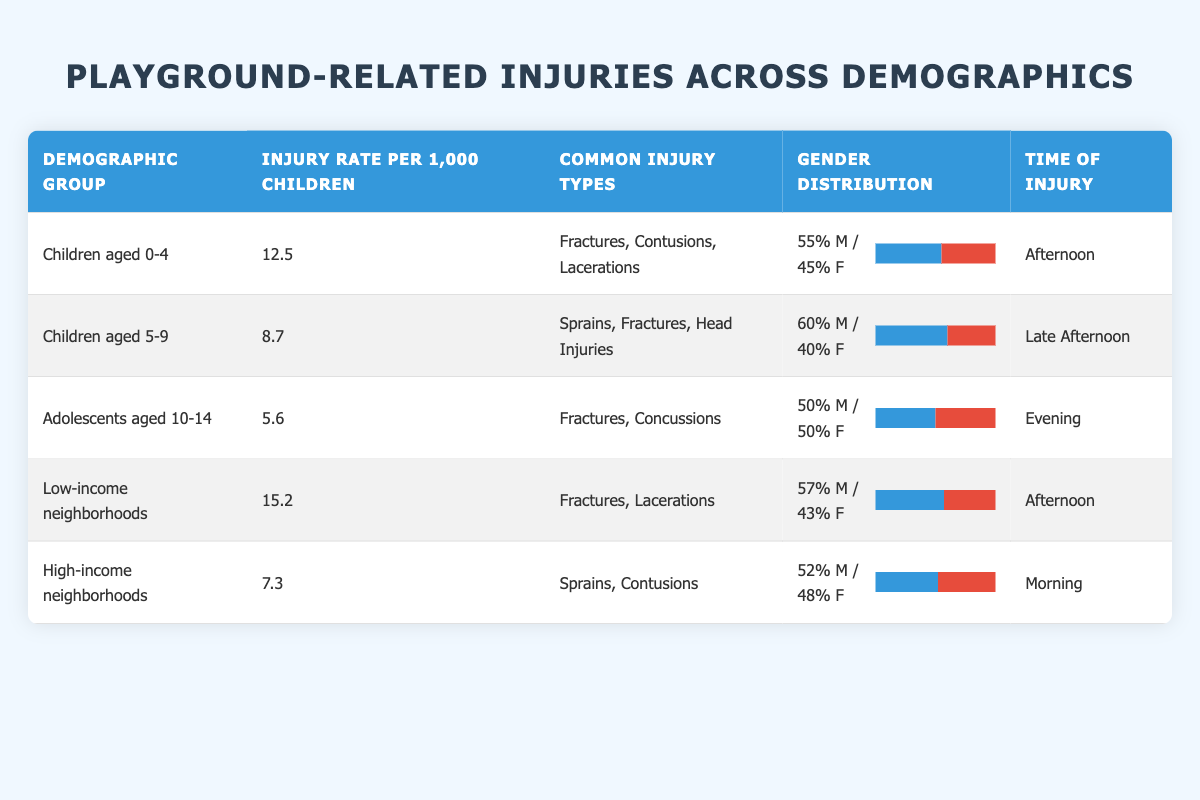What is the injury rate for children aged 0-4? The table lists the injury rate for children aged 0-4 in the column next to their demographic group, which is 12.5 per 1,000 children.
Answer: 12.5 Which demographic group has the highest injury rate? By examining the injury rates in the table, Low-income neighborhoods have the highest rate at 15.2 per 1,000 children.
Answer: Low-income neighborhoods Is the gender distribution for children aged 5-9 skewed towards males? The table shows that in the demographic group of children aged 5-9, the gender distribution is 60% male and 40% female. Since males make up a larger percentage than females, we can conclude it's skewed towards males.
Answer: Yes What are the common injury types for adolescents aged 10-14? The entry for adolescents aged 10-14 lists common injury types as Fractures and Concussions.
Answer: Fractures, Concussions Calculate the average injury rate for all the demographic groups presented in the table. To find the average, sum all the individual injury rates: 12.5 + 8.7 + 5.6 + 15.2 + 7.3 = 49.3. There are 5 groups, so the average injury rate is 49.3 / 5 = 9.86.
Answer: 9.86 Is it true that the time of injury for children in low-income neighborhoods is in the afternoon? According to the table, the time of injury for low-income neighborhoods is listed as Afternoon, thus this statement is true.
Answer: Yes What is the injury rate difference between high-income neighborhoods and children aged 0-4? To calculate the difference: the injury rate for children aged 0-4 is 12.5 and for high-income neighborhoods is 7.3. The difference is 12.5 - 7.3 = 5.2 per 1,000 children.
Answer: 5.2 How does the injury rate for children aged 5-9 compare to that of adolescents aged 10-14? The injury rate for children aged 5-9 is 8.7 while for adolescents aged 10-14 it is 5.6. Therefore, 8.7 is greater than 5.6, showing that children aged 5-9 experience more injuries.
Answer: 8.7 is greater than 5.6 Which demographic group has an equal gender distribution? In the table, the demographic group "Adolescents aged 10-14" shows an equal gender distribution, with 50% male and 50% female.
Answer: Adolescents aged 10-14 